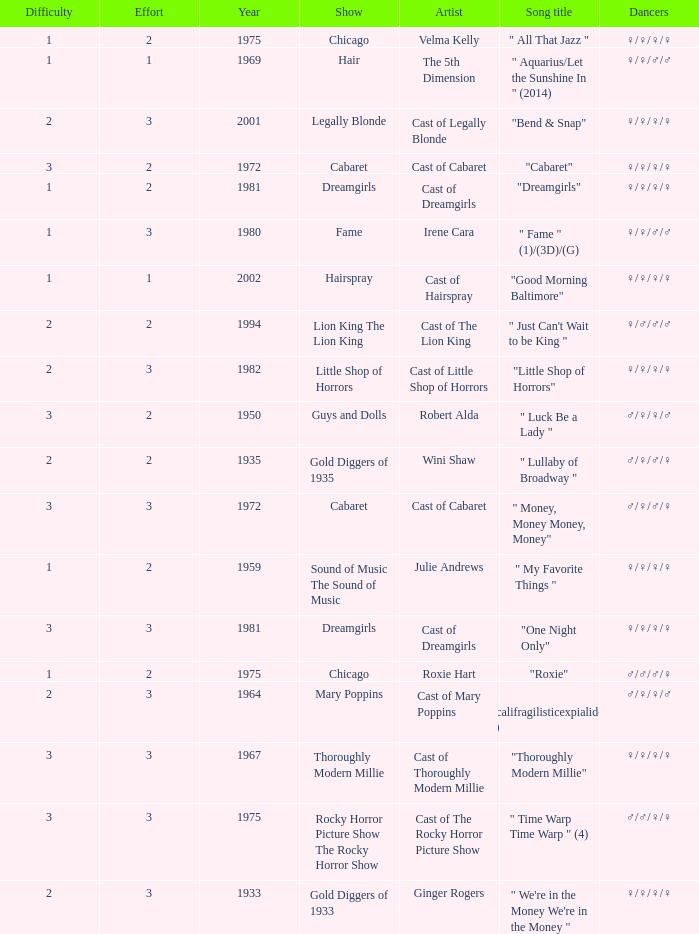How many shows were in 1994? 1.0. Help me parse the entirety of this table. {'header': ['Difficulty', 'Effort', 'Year', 'Show', 'Artist', 'Song title', 'Dancers'], 'rows': [['1', '2', '1975', 'Chicago', 'Velma Kelly', '" All That Jazz "', '♀/♀/♀/♀'], ['1', '1', '1969', 'Hair', 'The 5th Dimension', '" Aquarius/Let the Sunshine In " (2014)', '♀/♀/♂/♂'], ['2', '3', '2001', 'Legally Blonde', 'Cast of Legally Blonde', '"Bend & Snap"', '♀/♀/♀/♀'], ['3', '2', '1972', 'Cabaret', 'Cast of Cabaret', '"Cabaret"', '♀/♀/♀/♀'], ['1', '2', '1981', 'Dreamgirls', 'Cast of Dreamgirls', '"Dreamgirls"', '♀/♀/♀/♀'], ['1', '3', '1980', 'Fame', 'Irene Cara', '" Fame " (1)/(3D)/(G)', '♀/♀/♂/♂'], ['1', '1', '2002', 'Hairspray', 'Cast of Hairspray', '"Good Morning Baltimore"', '♀/♀/♀/♀'], ['2', '2', '1994', 'Lion King The Lion King', 'Cast of The Lion King', '" Just Can\'t Wait to be King "', '♀/♂/♂/♂'], ['2', '3', '1982', 'Little Shop of Horrors', 'Cast of Little Shop of Horrors', '"Little Shop of Horrors"', '♀/♀/♀/♀'], ['3', '2', '1950', 'Guys and Dolls', 'Robert Alda', '" Luck Be a Lady "', '♂/♀/♀/♂'], ['2', '2', '1935', 'Gold Diggers of 1935', 'Wini Shaw', '" Lullaby of Broadway "', '♂/♀/♂/♀'], ['3', '3', '1972', 'Cabaret', 'Cast of Cabaret', '" Money, Money Money, Money"', '♂/♀/♂/♀'], ['1', '2', '1959', 'Sound of Music The Sound of Music', 'Julie Andrews', '" My Favorite Things "', '♀/♀/♀/♀'], ['3', '3', '1981', 'Dreamgirls', 'Cast of Dreamgirls', '"One Night Only"', '♀/♀/♀/♀'], ['1', '2', '1975', 'Chicago', 'Roxie Hart', '"Roxie"', '♂/♂/♂/♀'], ['2', '3', '1964', 'Mary Poppins', 'Cast of Mary Poppins', '" Supercalifragilisticexpialidocious " (DP)', '♂/♀/♀/♂'], ['3', '3', '1967', 'Thoroughly Modern Millie', 'Cast of Thoroughly Modern Millie', '"Thoroughly Modern Millie"', '♀/♀/♀/♀'], ['3', '3', '1975', 'Rocky Horror Picture Show The Rocky Horror Show', 'Cast of The Rocky Horror Picture Show', '" Time Warp Time Warp " (4)', '♂/♂/♀/♀'], ['2', '3', '1933', 'Gold Diggers of 1933', 'Ginger Rogers', '" We\'re in the Money We\'re in the Money "', '♀/♀/♀/♀']]} 